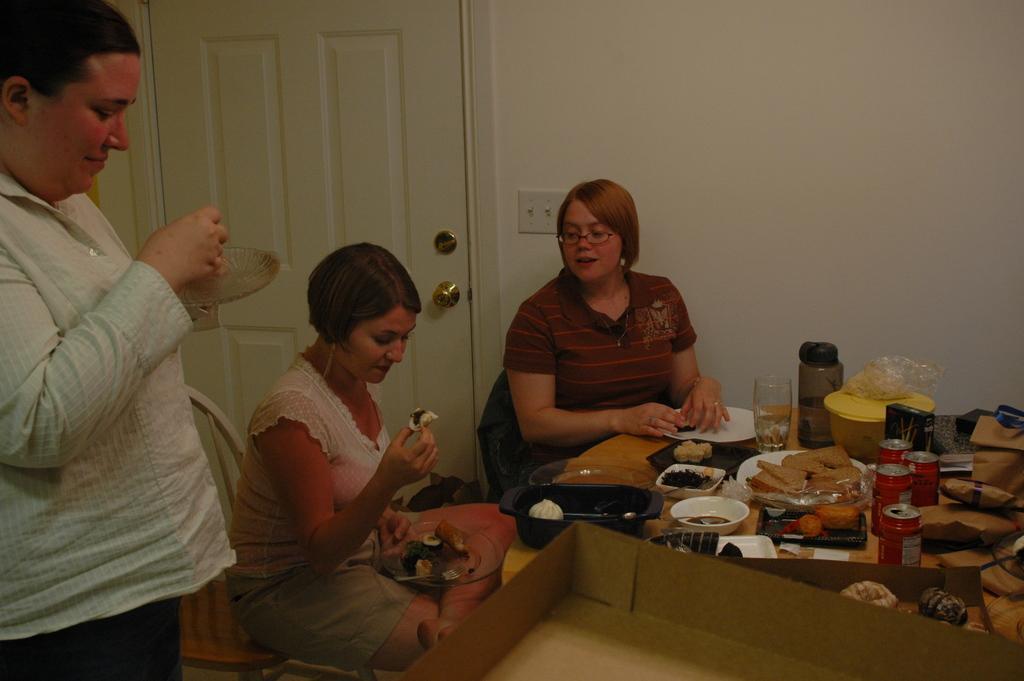Please provide a concise description of this image. In the center of the image we can see two ladies are sitting on the chairs. In-front of them, we can see a table. On the table we can see the bowl of food items, tins, glass, bottle, plates and some other objects. At the bottom of the image we can see a box. On the left side of the image we can see a lady is standing and holding a plate. In the background of the image we can see the wall, door, circuit board. 